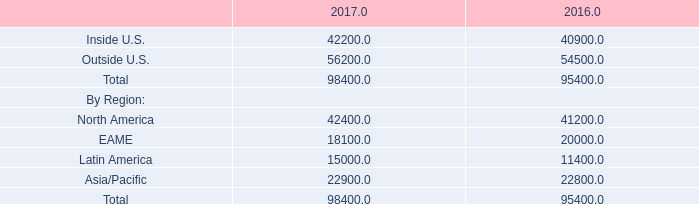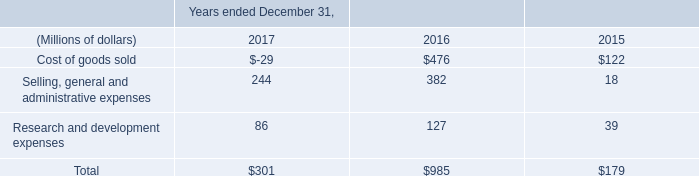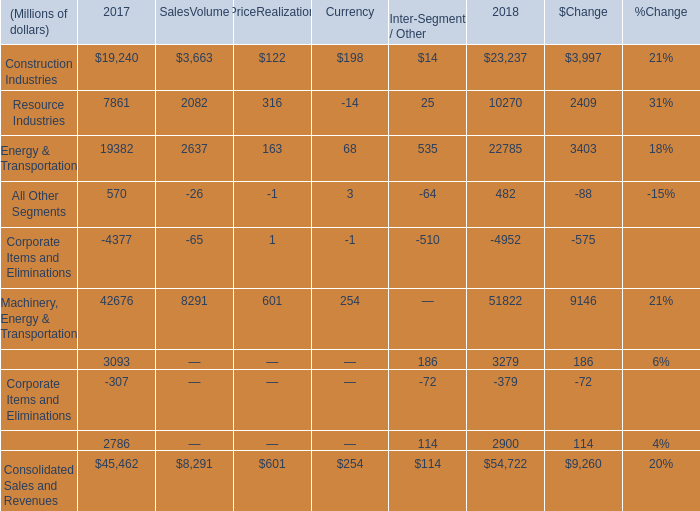What was the total amount of Resource Industries in 2018? (in million) 
Computations: ((((7861 + 2082) + 316) - 14) + 25)
Answer: 10270.0. 